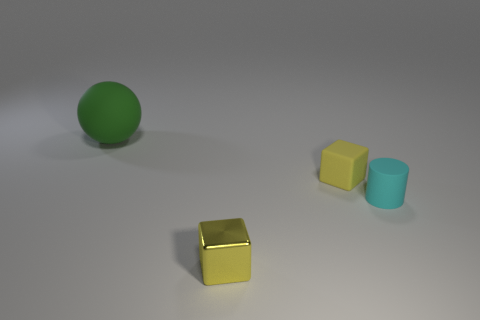Add 3 red metal objects. How many objects exist? 7 Subtract all cylinders. How many objects are left? 3 Add 1 small rubber blocks. How many small rubber blocks are left? 2 Add 1 small yellow metal spheres. How many small yellow metal spheres exist? 1 Subtract 0 green cubes. How many objects are left? 4 Subtract all cubes. Subtract all tiny cyan things. How many objects are left? 1 